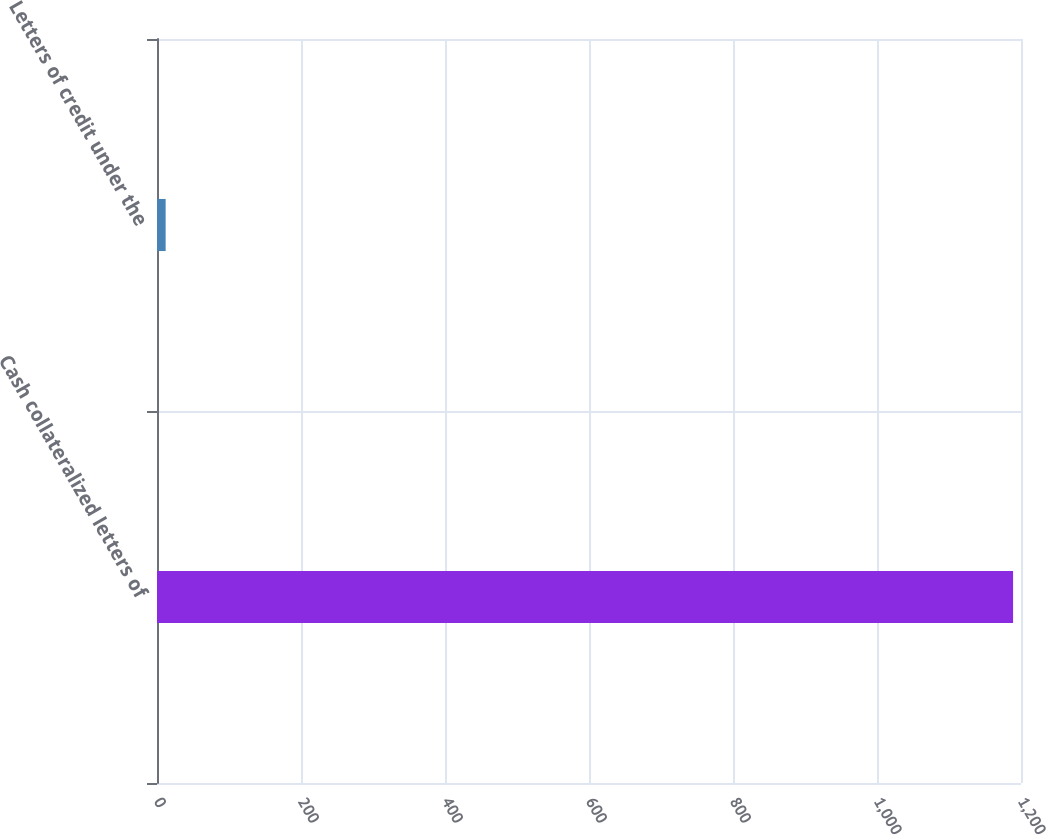<chart> <loc_0><loc_0><loc_500><loc_500><bar_chart><fcel>Cash collateralized letters of<fcel>Letters of credit under the<nl><fcel>1189<fcel>12<nl></chart> 